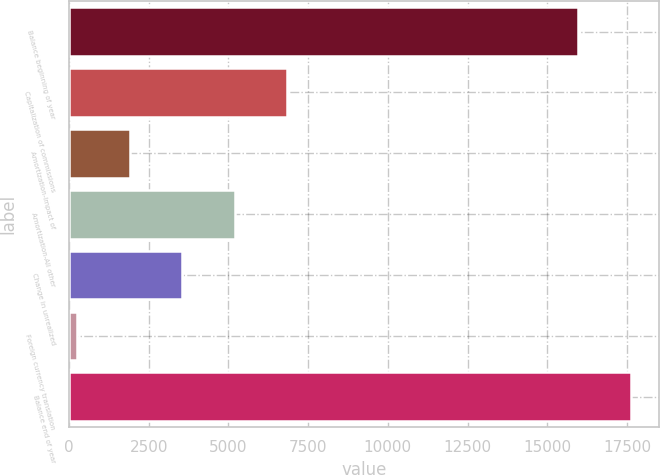Convert chart to OTSL. <chart><loc_0><loc_0><loc_500><loc_500><bar_chart><fcel>Balance beginning of year<fcel>Capitalization of commissions<fcel>Amortization-Impact of<fcel>Amortization-All other<fcel>Change in unrealized<fcel>Foreign currency translation<fcel>Balance end of year<nl><fcel>15971<fcel>6845<fcel>1908.5<fcel>5199.5<fcel>3554<fcel>263<fcel>17616.5<nl></chart> 